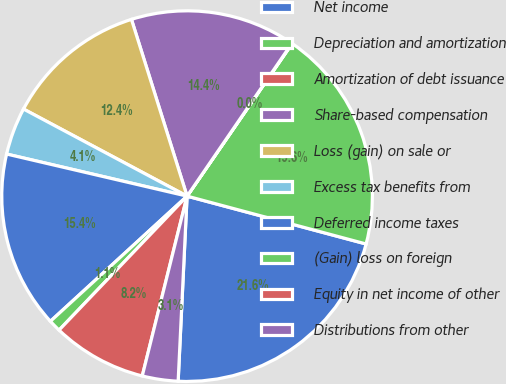Convert chart. <chart><loc_0><loc_0><loc_500><loc_500><pie_chart><fcel>Net income<fcel>Depreciation and amortization<fcel>Amortization of debt issuance<fcel>Share-based compensation<fcel>Loss (gain) on sale or<fcel>Excess tax benefits from<fcel>Deferred income taxes<fcel>(Gain) loss on foreign<fcel>Equity in net income of other<fcel>Distributions from other<nl><fcel>21.61%<fcel>19.56%<fcel>0.03%<fcel>14.42%<fcel>12.36%<fcel>4.14%<fcel>15.45%<fcel>1.06%<fcel>8.25%<fcel>3.12%<nl></chart> 